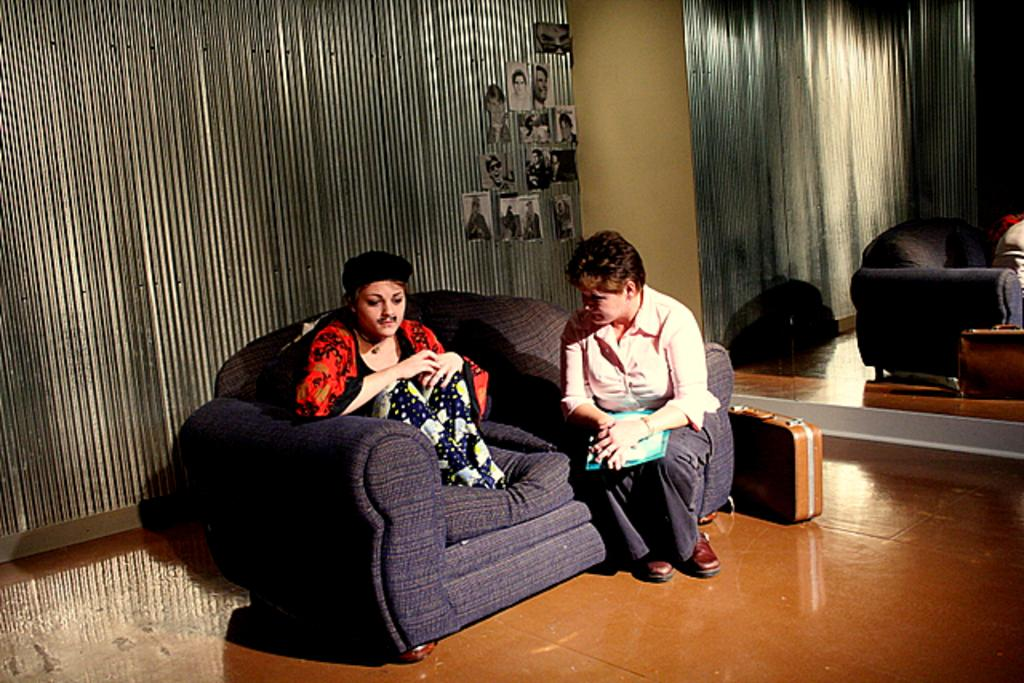How many people are sitting on the couch in the image? There are two persons sitting in a couch in the image. What are the two persons doing? The two persons are talking to each other. What can be seen in the background of the image? There is a briefcase, a mirror, a wall, and photos stuck to the wall in the background. What type of liquid is being poured from the tree in the image? There is no tree or liquid present in the image. 